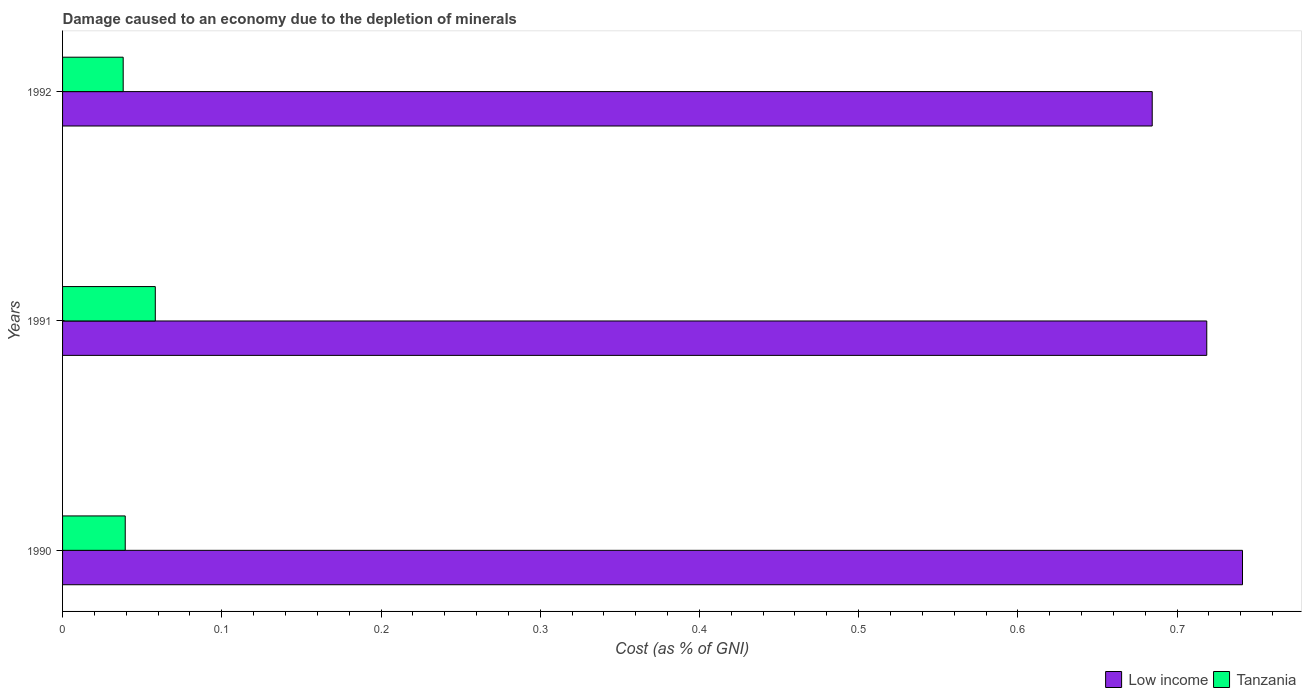How many groups of bars are there?
Provide a short and direct response. 3. Are the number of bars per tick equal to the number of legend labels?
Offer a very short reply. Yes. How many bars are there on the 2nd tick from the top?
Provide a succinct answer. 2. How many bars are there on the 1st tick from the bottom?
Make the answer very short. 2. In how many cases, is the number of bars for a given year not equal to the number of legend labels?
Give a very brief answer. 0. What is the cost of damage caused due to the depletion of minerals in Low income in 1990?
Keep it short and to the point. 0.74. Across all years, what is the maximum cost of damage caused due to the depletion of minerals in Tanzania?
Provide a short and direct response. 0.06. Across all years, what is the minimum cost of damage caused due to the depletion of minerals in Low income?
Your answer should be compact. 0.68. In which year was the cost of damage caused due to the depletion of minerals in Tanzania maximum?
Offer a terse response. 1991. In which year was the cost of damage caused due to the depletion of minerals in Low income minimum?
Your answer should be very brief. 1992. What is the total cost of damage caused due to the depletion of minerals in Tanzania in the graph?
Your answer should be compact. 0.14. What is the difference between the cost of damage caused due to the depletion of minerals in Low income in 1991 and that in 1992?
Make the answer very short. 0.03. What is the difference between the cost of damage caused due to the depletion of minerals in Tanzania in 1990 and the cost of damage caused due to the depletion of minerals in Low income in 1991?
Your answer should be very brief. -0.68. What is the average cost of damage caused due to the depletion of minerals in Tanzania per year?
Offer a terse response. 0.05. In the year 1992, what is the difference between the cost of damage caused due to the depletion of minerals in Low income and cost of damage caused due to the depletion of minerals in Tanzania?
Ensure brevity in your answer.  0.65. In how many years, is the cost of damage caused due to the depletion of minerals in Tanzania greater than 0.7000000000000001 %?
Ensure brevity in your answer.  0. What is the ratio of the cost of damage caused due to the depletion of minerals in Tanzania in 1990 to that in 1992?
Provide a short and direct response. 1.03. Is the cost of damage caused due to the depletion of minerals in Low income in 1991 less than that in 1992?
Offer a very short reply. No. What is the difference between the highest and the second highest cost of damage caused due to the depletion of minerals in Tanzania?
Your response must be concise. 0.02. What is the difference between the highest and the lowest cost of damage caused due to the depletion of minerals in Low income?
Your response must be concise. 0.06. In how many years, is the cost of damage caused due to the depletion of minerals in Tanzania greater than the average cost of damage caused due to the depletion of minerals in Tanzania taken over all years?
Give a very brief answer. 1. What does the 1st bar from the top in 1992 represents?
Your answer should be compact. Tanzania. What does the 2nd bar from the bottom in 1992 represents?
Provide a succinct answer. Tanzania. How many bars are there?
Your answer should be very brief. 6. How many years are there in the graph?
Give a very brief answer. 3. What is the difference between two consecutive major ticks on the X-axis?
Make the answer very short. 0.1. Does the graph contain grids?
Give a very brief answer. No. Where does the legend appear in the graph?
Your answer should be compact. Bottom right. How many legend labels are there?
Ensure brevity in your answer.  2. How are the legend labels stacked?
Provide a short and direct response. Horizontal. What is the title of the graph?
Your answer should be compact. Damage caused to an economy due to the depletion of minerals. What is the label or title of the X-axis?
Provide a short and direct response. Cost (as % of GNI). What is the Cost (as % of GNI) of Low income in 1990?
Your answer should be very brief. 0.74. What is the Cost (as % of GNI) of Tanzania in 1990?
Offer a terse response. 0.04. What is the Cost (as % of GNI) in Low income in 1991?
Your response must be concise. 0.72. What is the Cost (as % of GNI) in Tanzania in 1991?
Your answer should be very brief. 0.06. What is the Cost (as % of GNI) in Low income in 1992?
Your response must be concise. 0.68. What is the Cost (as % of GNI) in Tanzania in 1992?
Keep it short and to the point. 0.04. Across all years, what is the maximum Cost (as % of GNI) of Low income?
Your answer should be very brief. 0.74. Across all years, what is the maximum Cost (as % of GNI) of Tanzania?
Ensure brevity in your answer.  0.06. Across all years, what is the minimum Cost (as % of GNI) of Low income?
Provide a succinct answer. 0.68. Across all years, what is the minimum Cost (as % of GNI) in Tanzania?
Keep it short and to the point. 0.04. What is the total Cost (as % of GNI) of Low income in the graph?
Your response must be concise. 2.14. What is the total Cost (as % of GNI) of Tanzania in the graph?
Give a very brief answer. 0.14. What is the difference between the Cost (as % of GNI) of Low income in 1990 and that in 1991?
Make the answer very short. 0.02. What is the difference between the Cost (as % of GNI) of Tanzania in 1990 and that in 1991?
Provide a succinct answer. -0.02. What is the difference between the Cost (as % of GNI) of Low income in 1990 and that in 1992?
Your response must be concise. 0.06. What is the difference between the Cost (as % of GNI) in Tanzania in 1990 and that in 1992?
Offer a terse response. 0. What is the difference between the Cost (as % of GNI) in Low income in 1991 and that in 1992?
Give a very brief answer. 0.03. What is the difference between the Cost (as % of GNI) in Tanzania in 1991 and that in 1992?
Your response must be concise. 0.02. What is the difference between the Cost (as % of GNI) in Low income in 1990 and the Cost (as % of GNI) in Tanzania in 1991?
Your response must be concise. 0.68. What is the difference between the Cost (as % of GNI) in Low income in 1990 and the Cost (as % of GNI) in Tanzania in 1992?
Your answer should be very brief. 0.7. What is the difference between the Cost (as % of GNI) of Low income in 1991 and the Cost (as % of GNI) of Tanzania in 1992?
Your answer should be compact. 0.68. What is the average Cost (as % of GNI) of Low income per year?
Keep it short and to the point. 0.71. What is the average Cost (as % of GNI) in Tanzania per year?
Make the answer very short. 0.05. In the year 1990, what is the difference between the Cost (as % of GNI) of Low income and Cost (as % of GNI) of Tanzania?
Ensure brevity in your answer.  0.7. In the year 1991, what is the difference between the Cost (as % of GNI) in Low income and Cost (as % of GNI) in Tanzania?
Your answer should be very brief. 0.66. In the year 1992, what is the difference between the Cost (as % of GNI) of Low income and Cost (as % of GNI) of Tanzania?
Provide a short and direct response. 0.65. What is the ratio of the Cost (as % of GNI) of Low income in 1990 to that in 1991?
Your answer should be compact. 1.03. What is the ratio of the Cost (as % of GNI) of Tanzania in 1990 to that in 1991?
Ensure brevity in your answer.  0.68. What is the ratio of the Cost (as % of GNI) in Low income in 1990 to that in 1992?
Provide a short and direct response. 1.08. What is the ratio of the Cost (as % of GNI) in Tanzania in 1990 to that in 1992?
Provide a succinct answer. 1.03. What is the ratio of the Cost (as % of GNI) of Low income in 1991 to that in 1992?
Offer a very short reply. 1.05. What is the ratio of the Cost (as % of GNI) in Tanzania in 1991 to that in 1992?
Your answer should be very brief. 1.53. What is the difference between the highest and the second highest Cost (as % of GNI) of Low income?
Keep it short and to the point. 0.02. What is the difference between the highest and the second highest Cost (as % of GNI) of Tanzania?
Ensure brevity in your answer.  0.02. What is the difference between the highest and the lowest Cost (as % of GNI) in Low income?
Provide a short and direct response. 0.06. What is the difference between the highest and the lowest Cost (as % of GNI) in Tanzania?
Make the answer very short. 0.02. 